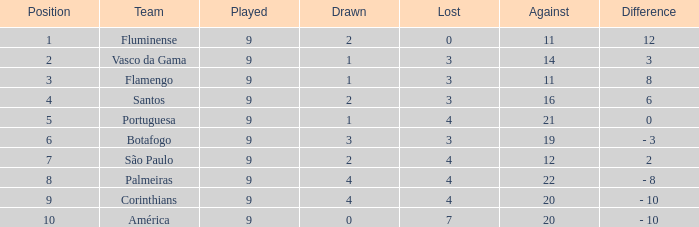Which Points is the highest one that has a Position of 1, and a Lost smaller than 0? None. 